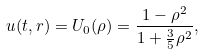<formula> <loc_0><loc_0><loc_500><loc_500>u ( t , r ) = U _ { 0 } ( \rho ) = \frac { 1 - \rho ^ { 2 } } { 1 + \frac { 3 } { 5 } \rho ^ { 2 } } ,</formula> 